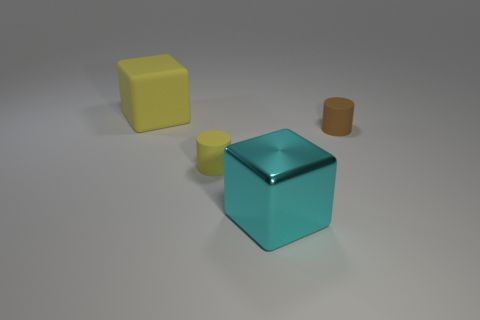Add 2 matte cylinders. How many objects exist? 6 Subtract all large yellow objects. Subtract all purple balls. How many objects are left? 3 Add 4 tiny yellow objects. How many tiny yellow objects are left? 5 Add 4 red metallic cylinders. How many red metallic cylinders exist? 4 Subtract 0 green cylinders. How many objects are left? 4 